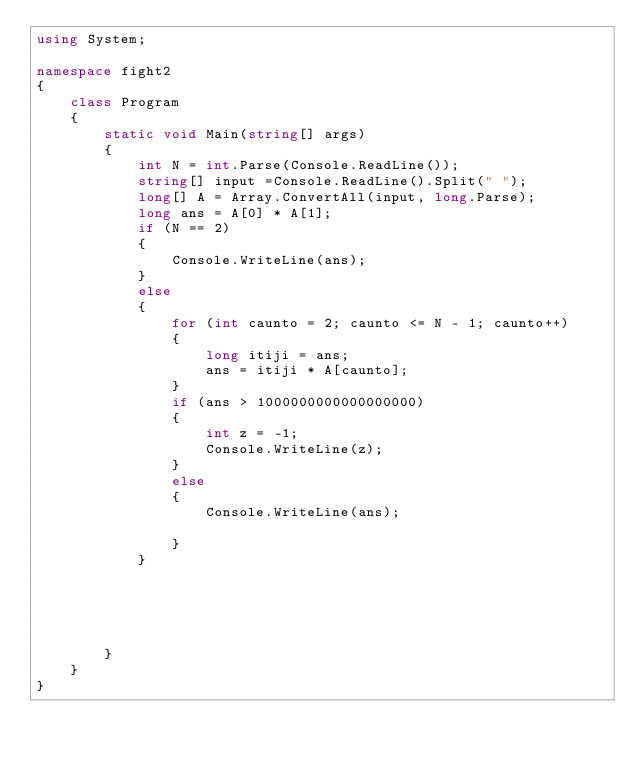Convert code to text. <code><loc_0><loc_0><loc_500><loc_500><_C#_>using System;

namespace fight2
{
    class Program
    {
        static void Main(string[] args)
        {
            int N = int.Parse(Console.ReadLine());
            string[] input =Console.ReadLine().Split(" ");
            long[] A = Array.ConvertAll(input, long.Parse);
            long ans = A[0] * A[1];
            if (N == 2) 
            {
                Console.WriteLine(ans); 
            }
            else
            {
                for (int caunto = 2; caunto <= N - 1; caunto++)
                {
                    long itiji = ans;
                    ans = itiji * A[caunto];
                }
                if (ans > 1000000000000000000)
                {
                    int z = -1;
                    Console.WriteLine(z);
                }
                else
                {
                    Console.WriteLine(ans);

                }
            }





        }
    }
}</code> 